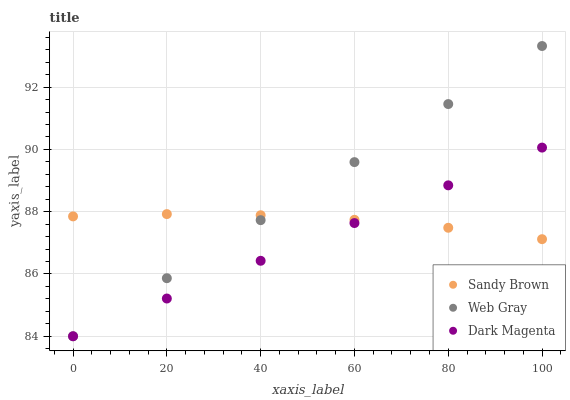Does Dark Magenta have the minimum area under the curve?
Answer yes or no. Yes. Does Web Gray have the maximum area under the curve?
Answer yes or no. Yes. Does Sandy Brown have the minimum area under the curve?
Answer yes or no. No. Does Sandy Brown have the maximum area under the curve?
Answer yes or no. No. Is Web Gray the smoothest?
Answer yes or no. Yes. Is Sandy Brown the roughest?
Answer yes or no. Yes. Is Dark Magenta the smoothest?
Answer yes or no. No. Is Dark Magenta the roughest?
Answer yes or no. No. Does Web Gray have the lowest value?
Answer yes or no. Yes. Does Sandy Brown have the lowest value?
Answer yes or no. No. Does Web Gray have the highest value?
Answer yes or no. Yes. Does Dark Magenta have the highest value?
Answer yes or no. No. Does Sandy Brown intersect Dark Magenta?
Answer yes or no. Yes. Is Sandy Brown less than Dark Magenta?
Answer yes or no. No. Is Sandy Brown greater than Dark Magenta?
Answer yes or no. No. 